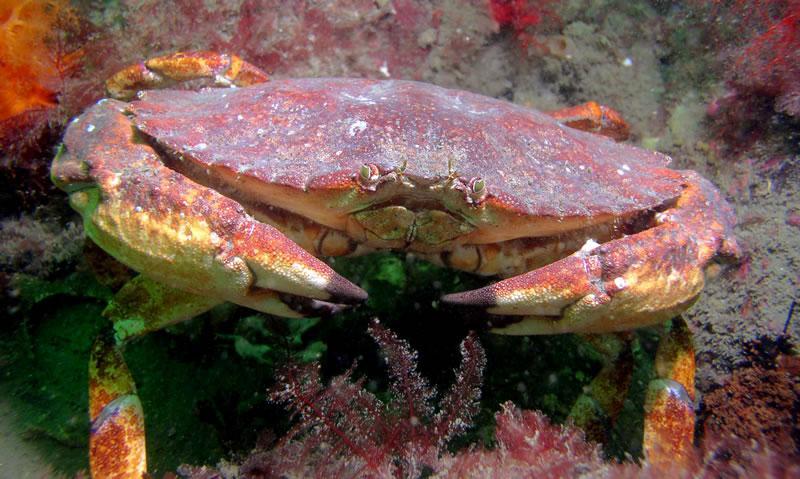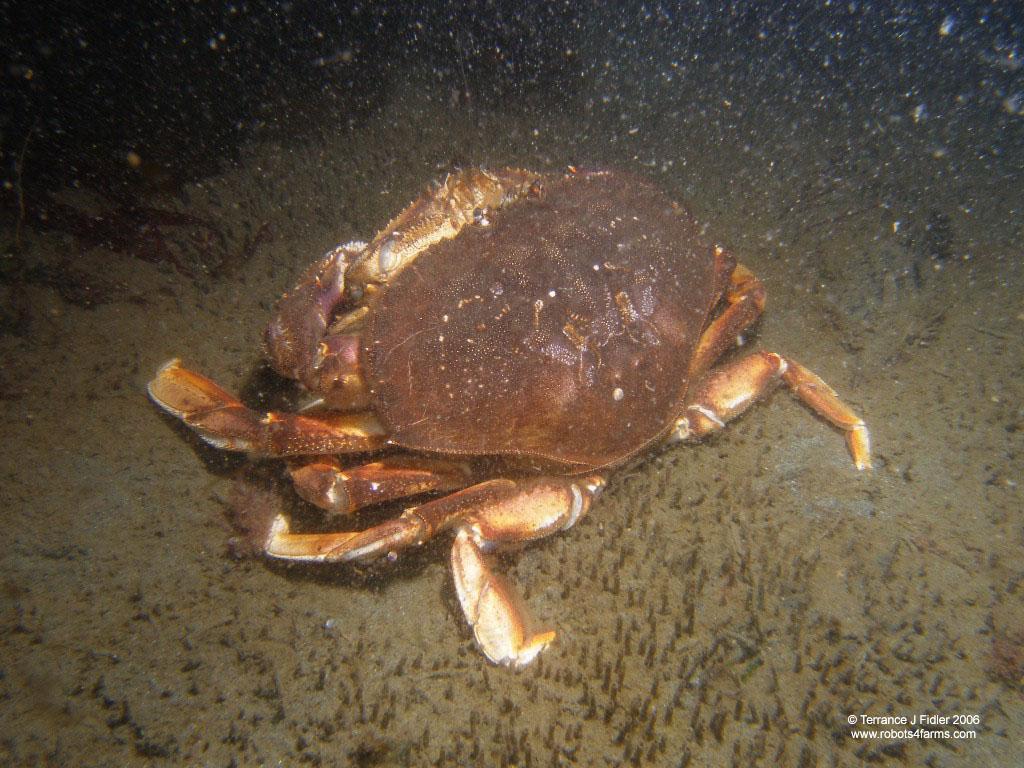The first image is the image on the left, the second image is the image on the right. Analyze the images presented: Is the assertion "Each image contains exactly one prominent forward-facing crab, and no image contains a part of a human." valid? Answer yes or no. No. The first image is the image on the left, the second image is the image on the right. For the images displayed, is the sentence "The left and right image contains the same number of sea animals." factually correct? Answer yes or no. Yes. 